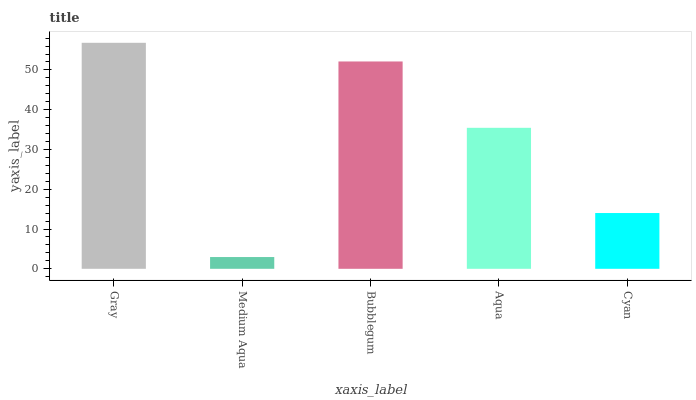Is Medium Aqua the minimum?
Answer yes or no. Yes. Is Gray the maximum?
Answer yes or no. Yes. Is Bubblegum the minimum?
Answer yes or no. No. Is Bubblegum the maximum?
Answer yes or no. No. Is Bubblegum greater than Medium Aqua?
Answer yes or no. Yes. Is Medium Aqua less than Bubblegum?
Answer yes or no. Yes. Is Medium Aqua greater than Bubblegum?
Answer yes or no. No. Is Bubblegum less than Medium Aqua?
Answer yes or no. No. Is Aqua the high median?
Answer yes or no. Yes. Is Aqua the low median?
Answer yes or no. Yes. Is Cyan the high median?
Answer yes or no. No. Is Medium Aqua the low median?
Answer yes or no. No. 